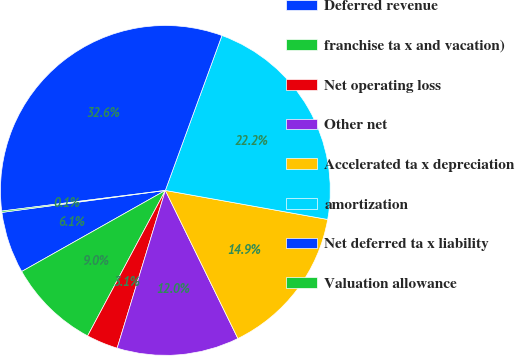Convert chart to OTSL. <chart><loc_0><loc_0><loc_500><loc_500><pie_chart><fcel>Deferred revenue<fcel>franchise ta x and vacation)<fcel>Net operating loss<fcel>Other net<fcel>Accelerated ta x depreciation<fcel>amortization<fcel>Net deferred ta x liability<fcel>Valuation allowance<nl><fcel>6.05%<fcel>9.01%<fcel>3.09%<fcel>11.97%<fcel>14.93%<fcel>22.24%<fcel>32.57%<fcel>0.13%<nl></chart> 